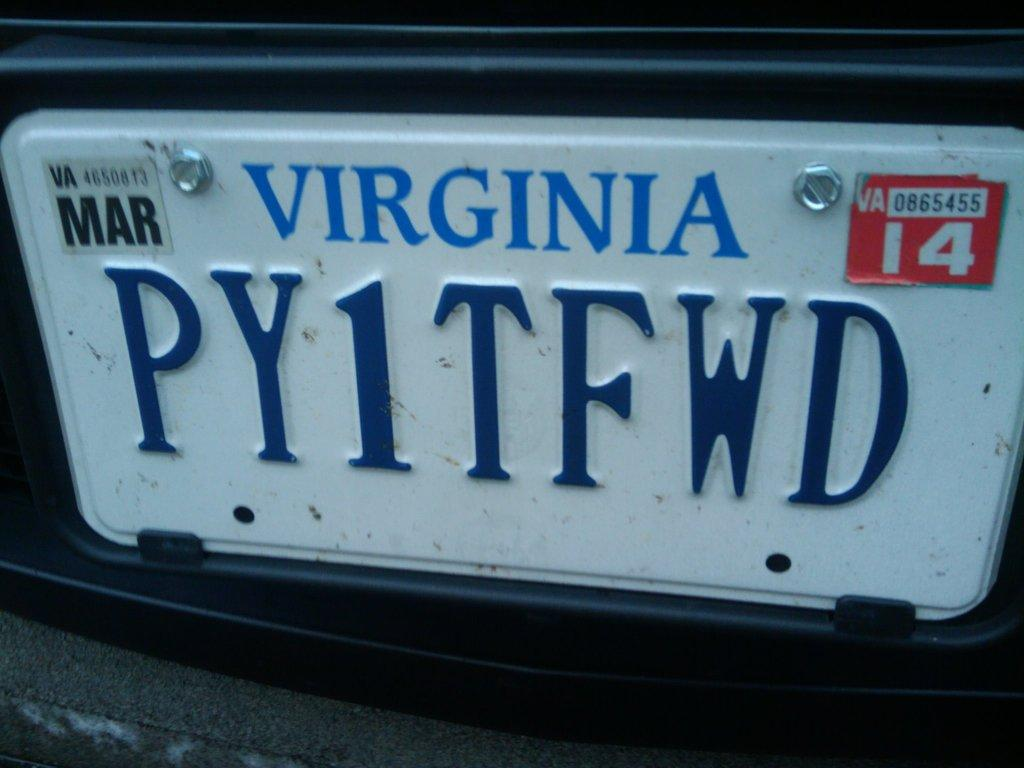<image>
Provide a brief description of the given image. a close up of a Virginia license plate PY1TFWD 